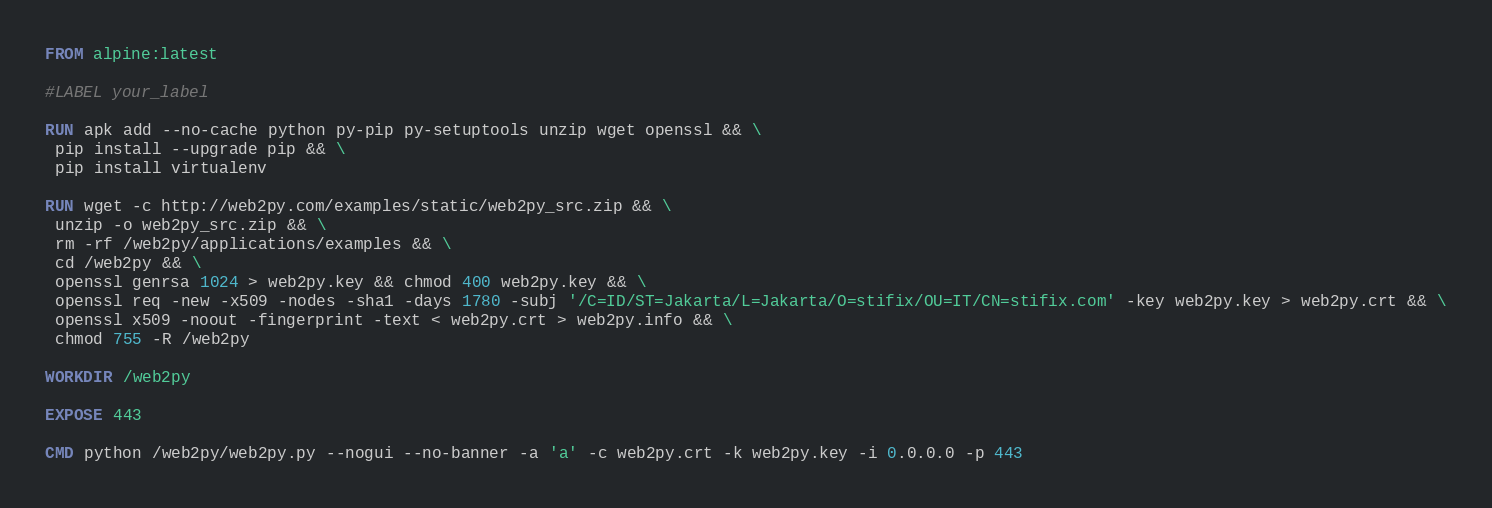Convert code to text. <code><loc_0><loc_0><loc_500><loc_500><_Dockerfile_>FROM alpine:latest

#LABEL your_label

RUN apk add --no-cache python py-pip py-setuptools unzip wget openssl && \
 pip install --upgrade pip && \
 pip install virtualenv 

RUN wget -c http://web2py.com/examples/static/web2py_src.zip && \
 unzip -o web2py_src.zip && \
 rm -rf /web2py/applications/examples && \
 cd /web2py && \
 openssl genrsa 1024 > web2py.key && chmod 400 web2py.key && \
 openssl req -new -x509 -nodes -sha1 -days 1780 -subj '/C=ID/ST=Jakarta/L=Jakarta/O=stifix/OU=IT/CN=stifix.com' -key web2py.key > web2py.crt && \
 openssl x509 -noout -fingerprint -text < web2py.crt > web2py.info && \
 chmod 755 -R /web2py

WORKDIR /web2py

EXPOSE 443

CMD python /web2py/web2py.py --nogui --no-banner -a 'a' -c web2py.crt -k web2py.key -i 0.0.0.0 -p 443
</code> 